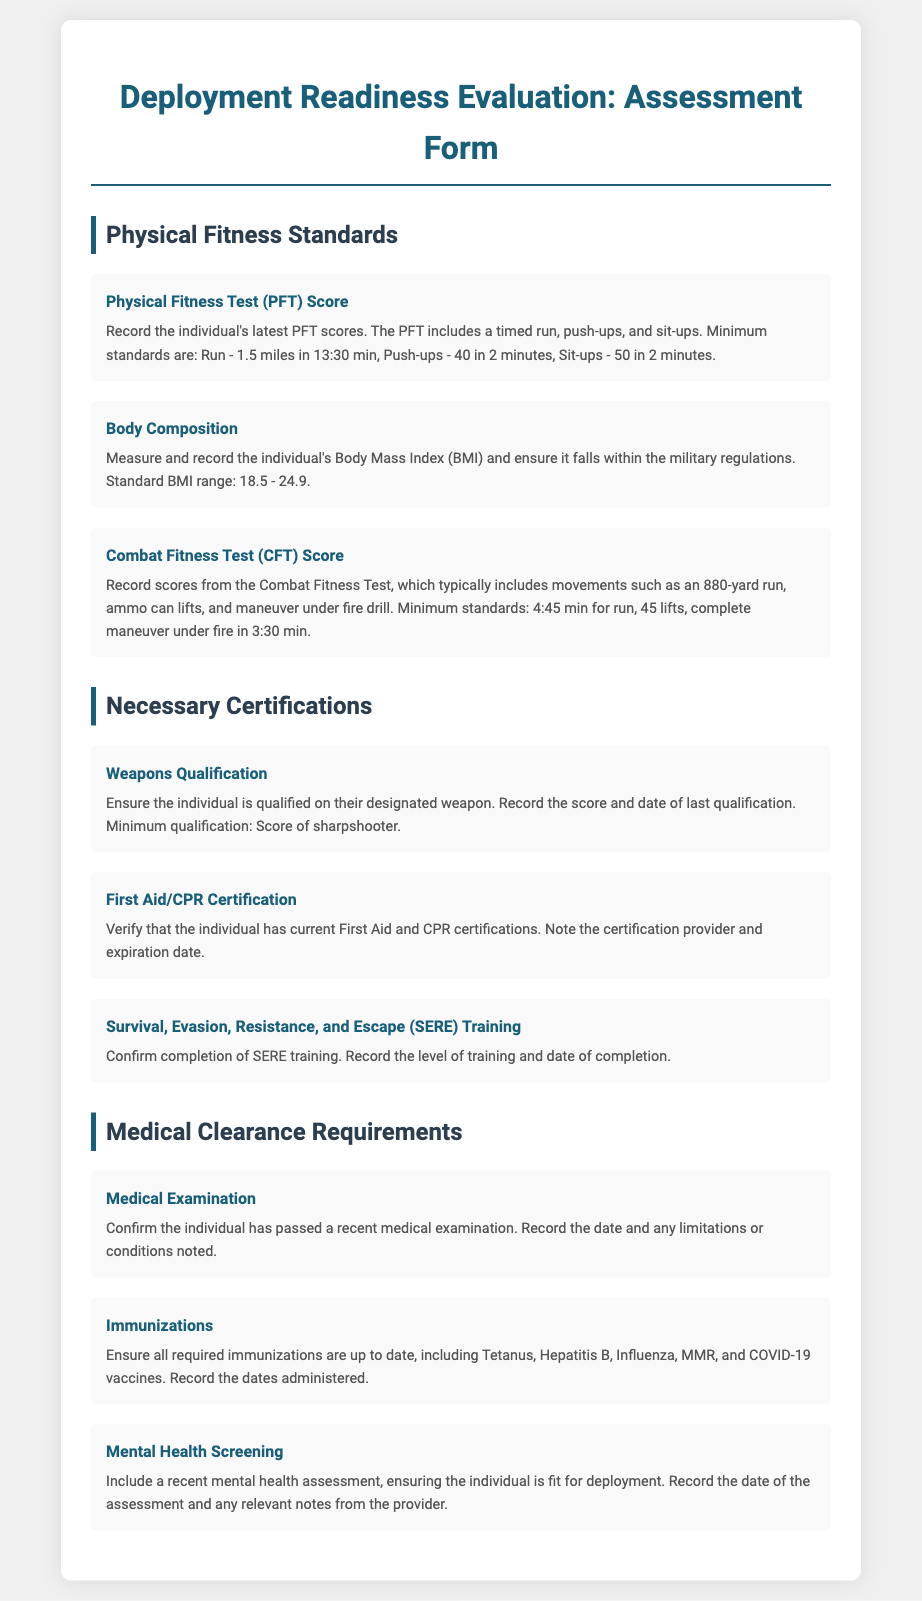what is the minimum time for the 1.5-mile run in the PFT? The document states that the minimum standard for the run is 1.5 miles in 13:30 minutes.
Answer: 13:30 min what is the required BMI range according to the document? The standard Body Mass Index (BMI) range specified in the document is between 18.5 and 24.9.
Answer: 18.5 - 24.9 how many push-ups must be completed in 2 minutes for the PFT? The document indicates that a minimum of 40 push-ups must be completed in 2 minutes for the PFT.
Answer: 40 what score is required for Weapons Qualification? The document mentions that the minimum qualification score required is a score of sharpshooter.
Answer: sharpshooter what type of training must be confirmed for SERE? The document requests confirmation of the completion of Survival, Evasion, Resistance, and Escape (SERE) training.
Answer: SERE training what is the minimum lift requirement in the Combat Fitness Test? According to the document, the minimum number of ammo can lifts required is 45.
Answer: 45 lifts what is the required immunization mentioned in the document? The document lists Tetanus, Hepatitis B, Influenza, MMR, and COVID-19 vaccines as required immunizations.
Answer: Tetanus, Hepatitis B, Influenza, MMR, COVID-19 when should the Medical Examination be confirmed by? The document states that the individual must have passed a recent medical examination, but does not specify a date, implying it should be current.
Answer: recent what should be recorded during the Mental Health Screening? The document specifies that the date of the assessment and any relevant notes from the provider should be recorded.
Answer: date and relevant notes 